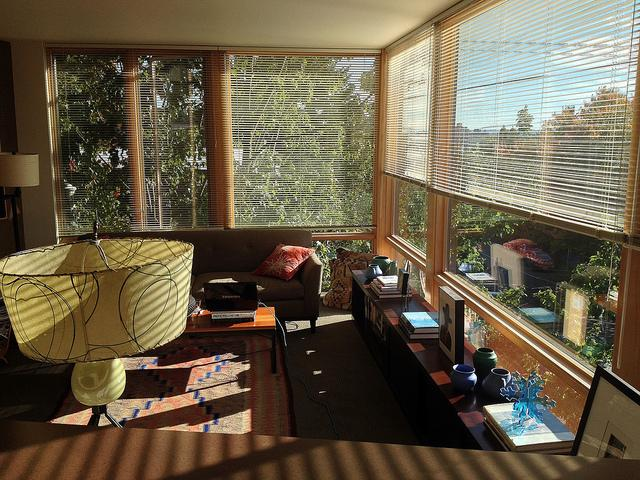How many items in the living room may have to share an outlet with the laptop?

Choices:
A) five
B) three
C) two
D) four two 